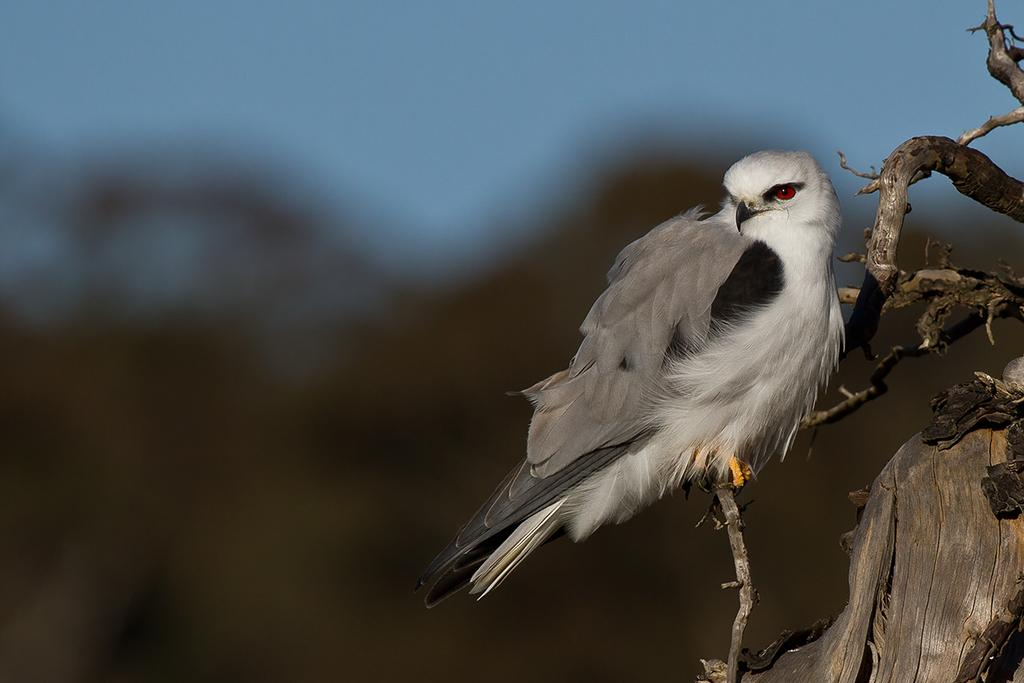What type of animal can be seen in the image? There is a bird in the image. Where is the bird located? The bird is on a tree branch. Can you describe the background of the image? The background of the image is blurred and has blue and brown colors. What type of door can be seen in the image? There is no door present in the image; it features a bird on a tree branch with a blurred background. 